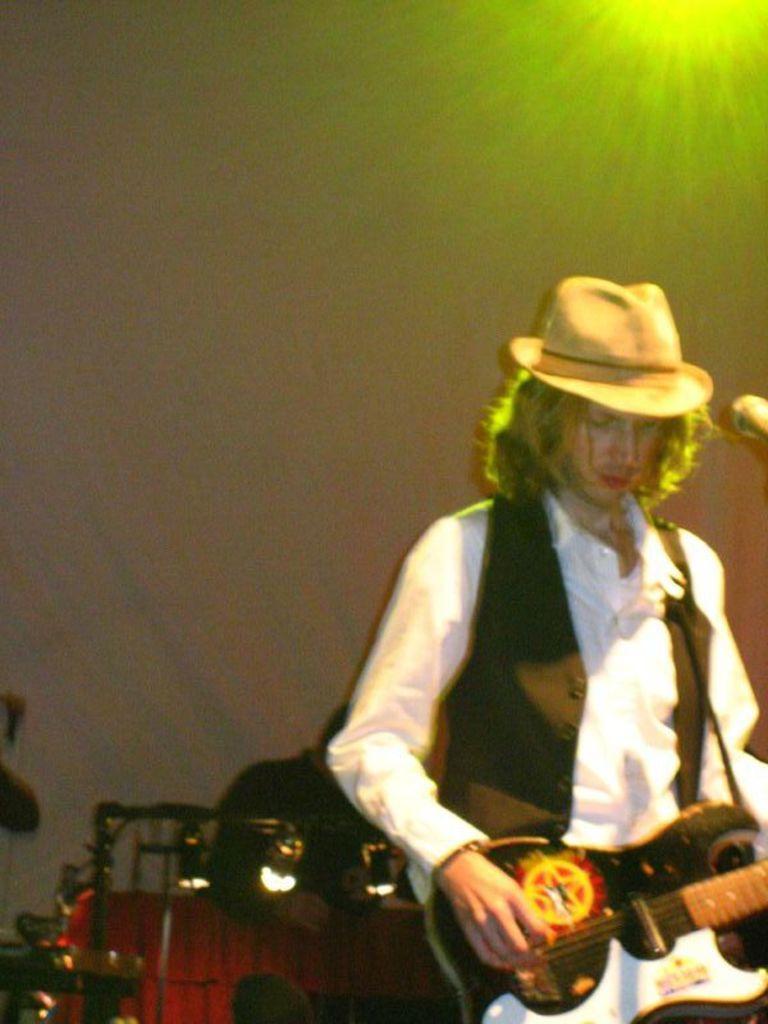How would you summarize this image in a sentence or two? This image consists of a man wearing a white shirt and black vase coat is playing a guitar. In the background, there is another person playing drums and there is clothed in white color. At the top, we can see a light ray. 